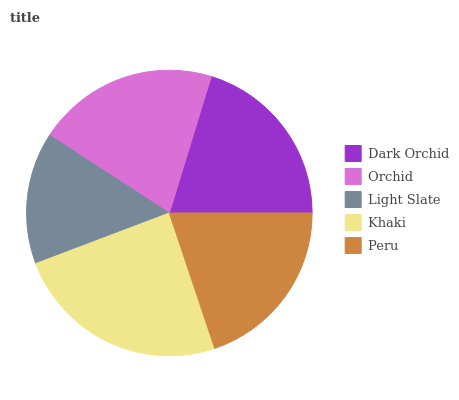Is Light Slate the minimum?
Answer yes or no. Yes. Is Khaki the maximum?
Answer yes or no. Yes. Is Orchid the minimum?
Answer yes or no. No. Is Orchid the maximum?
Answer yes or no. No. Is Orchid greater than Dark Orchid?
Answer yes or no. Yes. Is Dark Orchid less than Orchid?
Answer yes or no. Yes. Is Dark Orchid greater than Orchid?
Answer yes or no. No. Is Orchid less than Dark Orchid?
Answer yes or no. No. Is Dark Orchid the high median?
Answer yes or no. Yes. Is Dark Orchid the low median?
Answer yes or no. Yes. Is Light Slate the high median?
Answer yes or no. No. Is Orchid the low median?
Answer yes or no. No. 